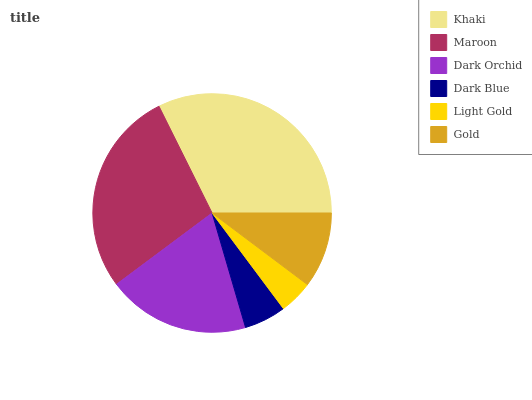Is Light Gold the minimum?
Answer yes or no. Yes. Is Khaki the maximum?
Answer yes or no. Yes. Is Maroon the minimum?
Answer yes or no. No. Is Maroon the maximum?
Answer yes or no. No. Is Khaki greater than Maroon?
Answer yes or no. Yes. Is Maroon less than Khaki?
Answer yes or no. Yes. Is Maroon greater than Khaki?
Answer yes or no. No. Is Khaki less than Maroon?
Answer yes or no. No. Is Dark Orchid the high median?
Answer yes or no. Yes. Is Gold the low median?
Answer yes or no. Yes. Is Khaki the high median?
Answer yes or no. No. Is Dark Blue the low median?
Answer yes or no. No. 